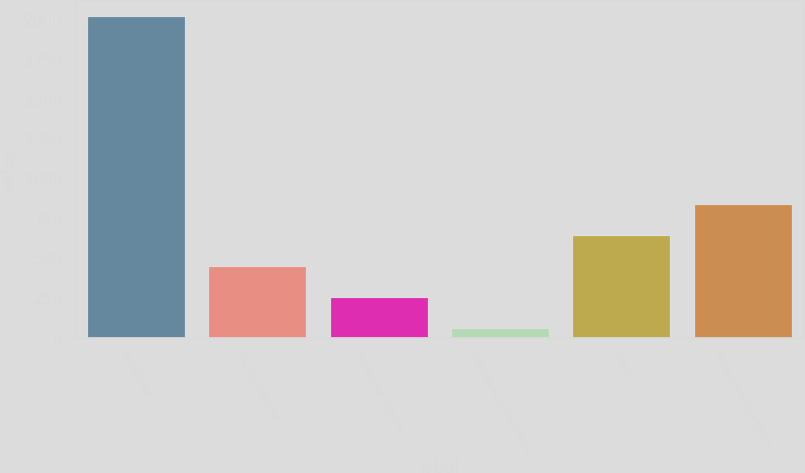Convert chart to OTSL. <chart><loc_0><loc_0><loc_500><loc_500><bar_chart><fcel>(in millions)<fcel>Deposit insurance<fcel>Promotional expense<fcel>Settlements and operating<fcel>Other<fcel>Other operating expense<nl><fcel>2017<fcel>446.6<fcel>250.3<fcel>54<fcel>642.9<fcel>839.2<nl></chart> 